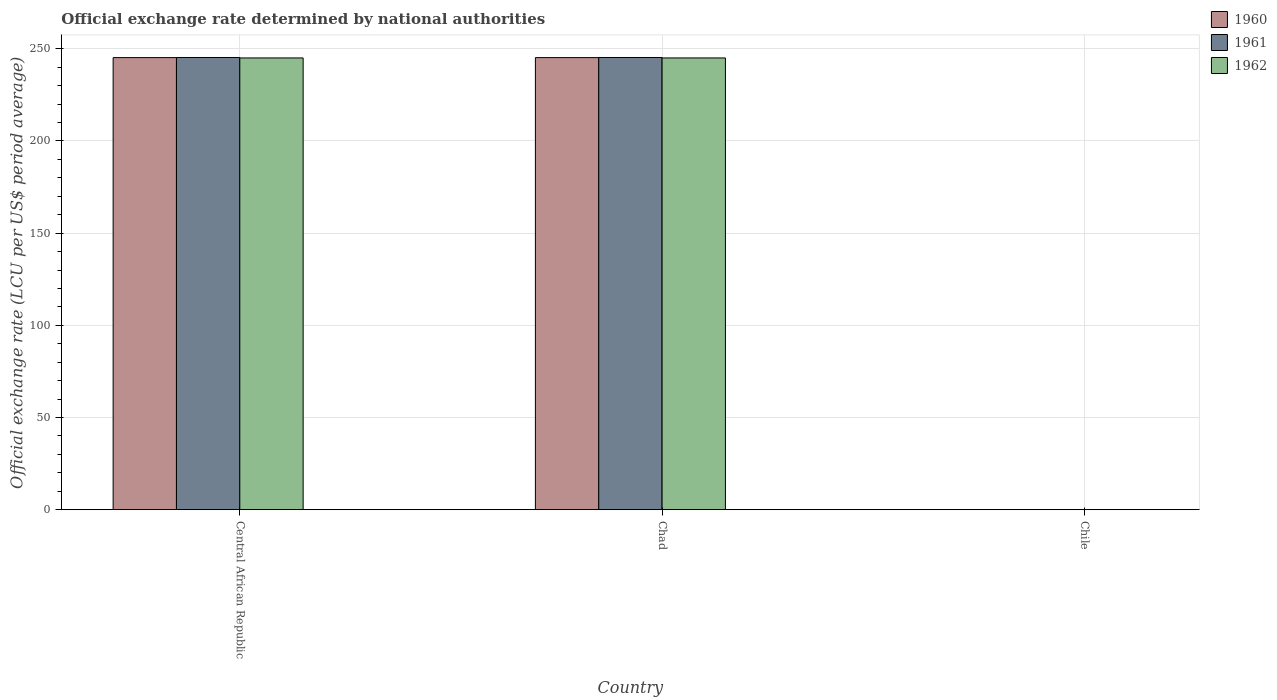How many groups of bars are there?
Offer a terse response. 3. What is the label of the 2nd group of bars from the left?
Keep it short and to the point. Chad. What is the official exchange rate in 1960 in Central African Republic?
Offer a terse response. 245.2. Across all countries, what is the maximum official exchange rate in 1961?
Your response must be concise. 245.26. Across all countries, what is the minimum official exchange rate in 1962?
Offer a terse response. 0. In which country was the official exchange rate in 1961 maximum?
Provide a succinct answer. Central African Republic. What is the total official exchange rate in 1961 in the graph?
Your answer should be very brief. 490.52. What is the difference between the official exchange rate in 1961 in Chad and that in Chile?
Provide a short and direct response. 245.26. What is the difference between the official exchange rate in 1960 in Chile and the official exchange rate in 1962 in Central African Republic?
Ensure brevity in your answer.  -245.01. What is the average official exchange rate in 1962 per country?
Ensure brevity in your answer.  163.34. What is the difference between the official exchange rate of/in 1962 and official exchange rate of/in 1960 in Chile?
Provide a short and direct response. 8.666413905490016e-6. What is the ratio of the official exchange rate in 1962 in Central African Republic to that in Chile?
Provide a short and direct response. 2.32e+05. Is the difference between the official exchange rate in 1962 in Central African Republic and Chile greater than the difference between the official exchange rate in 1960 in Central African Republic and Chile?
Give a very brief answer. No. What is the difference between the highest and the second highest official exchange rate in 1960?
Give a very brief answer. -245.19. What is the difference between the highest and the lowest official exchange rate in 1960?
Offer a terse response. 245.19. Is the sum of the official exchange rate in 1961 in Central African Republic and Chile greater than the maximum official exchange rate in 1960 across all countries?
Ensure brevity in your answer.  Yes. What does the 2nd bar from the left in Chad represents?
Offer a terse response. 1961. What does the 1st bar from the right in Central African Republic represents?
Offer a very short reply. 1962. Is it the case that in every country, the sum of the official exchange rate in 1960 and official exchange rate in 1962 is greater than the official exchange rate in 1961?
Your answer should be compact. Yes. What is the difference between two consecutive major ticks on the Y-axis?
Your answer should be compact. 50. Are the values on the major ticks of Y-axis written in scientific E-notation?
Provide a succinct answer. No. Does the graph contain any zero values?
Make the answer very short. No. Where does the legend appear in the graph?
Make the answer very short. Top right. What is the title of the graph?
Your answer should be very brief. Official exchange rate determined by national authorities. Does "1981" appear as one of the legend labels in the graph?
Give a very brief answer. No. What is the label or title of the Y-axis?
Your answer should be very brief. Official exchange rate (LCU per US$ period average). What is the Official exchange rate (LCU per US$ period average) in 1960 in Central African Republic?
Offer a very short reply. 245.2. What is the Official exchange rate (LCU per US$ period average) in 1961 in Central African Republic?
Your answer should be very brief. 245.26. What is the Official exchange rate (LCU per US$ period average) in 1962 in Central African Republic?
Your answer should be compact. 245.01. What is the Official exchange rate (LCU per US$ period average) of 1960 in Chad?
Your answer should be very brief. 245.2. What is the Official exchange rate (LCU per US$ period average) of 1961 in Chad?
Ensure brevity in your answer.  245.26. What is the Official exchange rate (LCU per US$ period average) in 1962 in Chad?
Keep it short and to the point. 245.01. What is the Official exchange rate (LCU per US$ period average) in 1960 in Chile?
Offer a terse response. 0. What is the Official exchange rate (LCU per US$ period average) in 1961 in Chile?
Keep it short and to the point. 0. What is the Official exchange rate (LCU per US$ period average) of 1962 in Chile?
Your answer should be very brief. 0. Across all countries, what is the maximum Official exchange rate (LCU per US$ period average) of 1960?
Keep it short and to the point. 245.2. Across all countries, what is the maximum Official exchange rate (LCU per US$ period average) of 1961?
Offer a very short reply. 245.26. Across all countries, what is the maximum Official exchange rate (LCU per US$ period average) of 1962?
Keep it short and to the point. 245.01. Across all countries, what is the minimum Official exchange rate (LCU per US$ period average) in 1960?
Provide a short and direct response. 0. Across all countries, what is the minimum Official exchange rate (LCU per US$ period average) of 1961?
Offer a terse response. 0. Across all countries, what is the minimum Official exchange rate (LCU per US$ period average) of 1962?
Provide a short and direct response. 0. What is the total Official exchange rate (LCU per US$ period average) of 1960 in the graph?
Your response must be concise. 490.39. What is the total Official exchange rate (LCU per US$ period average) in 1961 in the graph?
Give a very brief answer. 490.52. What is the total Official exchange rate (LCU per US$ period average) in 1962 in the graph?
Ensure brevity in your answer.  490.03. What is the difference between the Official exchange rate (LCU per US$ period average) in 1960 in Central African Republic and that in Chile?
Ensure brevity in your answer.  245.19. What is the difference between the Official exchange rate (LCU per US$ period average) in 1961 in Central African Republic and that in Chile?
Keep it short and to the point. 245.26. What is the difference between the Official exchange rate (LCU per US$ period average) in 1962 in Central African Republic and that in Chile?
Your response must be concise. 245.01. What is the difference between the Official exchange rate (LCU per US$ period average) in 1960 in Chad and that in Chile?
Provide a short and direct response. 245.19. What is the difference between the Official exchange rate (LCU per US$ period average) in 1961 in Chad and that in Chile?
Give a very brief answer. 245.26. What is the difference between the Official exchange rate (LCU per US$ period average) of 1962 in Chad and that in Chile?
Your answer should be very brief. 245.01. What is the difference between the Official exchange rate (LCU per US$ period average) in 1960 in Central African Republic and the Official exchange rate (LCU per US$ period average) in 1961 in Chad?
Provide a short and direct response. -0.07. What is the difference between the Official exchange rate (LCU per US$ period average) of 1960 in Central African Republic and the Official exchange rate (LCU per US$ period average) of 1962 in Chad?
Offer a very short reply. 0.18. What is the difference between the Official exchange rate (LCU per US$ period average) of 1961 in Central African Republic and the Official exchange rate (LCU per US$ period average) of 1962 in Chad?
Your answer should be compact. 0.25. What is the difference between the Official exchange rate (LCU per US$ period average) in 1960 in Central African Republic and the Official exchange rate (LCU per US$ period average) in 1961 in Chile?
Ensure brevity in your answer.  245.19. What is the difference between the Official exchange rate (LCU per US$ period average) in 1960 in Central African Republic and the Official exchange rate (LCU per US$ period average) in 1962 in Chile?
Offer a very short reply. 245.19. What is the difference between the Official exchange rate (LCU per US$ period average) of 1961 in Central African Republic and the Official exchange rate (LCU per US$ period average) of 1962 in Chile?
Your answer should be compact. 245.26. What is the difference between the Official exchange rate (LCU per US$ period average) in 1960 in Chad and the Official exchange rate (LCU per US$ period average) in 1961 in Chile?
Provide a short and direct response. 245.19. What is the difference between the Official exchange rate (LCU per US$ period average) of 1960 in Chad and the Official exchange rate (LCU per US$ period average) of 1962 in Chile?
Make the answer very short. 245.19. What is the difference between the Official exchange rate (LCU per US$ period average) of 1961 in Chad and the Official exchange rate (LCU per US$ period average) of 1962 in Chile?
Offer a very short reply. 245.26. What is the average Official exchange rate (LCU per US$ period average) in 1960 per country?
Provide a succinct answer. 163.46. What is the average Official exchange rate (LCU per US$ period average) in 1961 per country?
Your answer should be compact. 163.51. What is the average Official exchange rate (LCU per US$ period average) of 1962 per country?
Give a very brief answer. 163.34. What is the difference between the Official exchange rate (LCU per US$ period average) of 1960 and Official exchange rate (LCU per US$ period average) of 1961 in Central African Republic?
Your answer should be compact. -0.07. What is the difference between the Official exchange rate (LCU per US$ period average) of 1960 and Official exchange rate (LCU per US$ period average) of 1962 in Central African Republic?
Keep it short and to the point. 0.18. What is the difference between the Official exchange rate (LCU per US$ period average) of 1961 and Official exchange rate (LCU per US$ period average) of 1962 in Central African Republic?
Offer a very short reply. 0.25. What is the difference between the Official exchange rate (LCU per US$ period average) of 1960 and Official exchange rate (LCU per US$ period average) of 1961 in Chad?
Your response must be concise. -0.07. What is the difference between the Official exchange rate (LCU per US$ period average) in 1960 and Official exchange rate (LCU per US$ period average) in 1962 in Chad?
Keep it short and to the point. 0.18. What is the difference between the Official exchange rate (LCU per US$ period average) in 1961 and Official exchange rate (LCU per US$ period average) in 1962 in Chad?
Give a very brief answer. 0.25. What is the difference between the Official exchange rate (LCU per US$ period average) in 1960 and Official exchange rate (LCU per US$ period average) in 1961 in Chile?
Provide a succinct answer. -0. What is the difference between the Official exchange rate (LCU per US$ period average) of 1960 and Official exchange rate (LCU per US$ period average) of 1962 in Chile?
Ensure brevity in your answer.  -0. What is the ratio of the Official exchange rate (LCU per US$ period average) of 1960 in Central African Republic to that in Chile?
Give a very brief answer. 2.34e+05. What is the ratio of the Official exchange rate (LCU per US$ period average) in 1961 in Central African Republic to that in Chile?
Your answer should be very brief. 2.34e+05. What is the ratio of the Official exchange rate (LCU per US$ period average) of 1962 in Central African Republic to that in Chile?
Your response must be concise. 2.32e+05. What is the ratio of the Official exchange rate (LCU per US$ period average) in 1960 in Chad to that in Chile?
Your answer should be very brief. 2.34e+05. What is the ratio of the Official exchange rate (LCU per US$ period average) of 1961 in Chad to that in Chile?
Offer a terse response. 2.34e+05. What is the ratio of the Official exchange rate (LCU per US$ period average) in 1962 in Chad to that in Chile?
Offer a terse response. 2.32e+05. What is the difference between the highest and the second highest Official exchange rate (LCU per US$ period average) in 1960?
Make the answer very short. 0. What is the difference between the highest and the second highest Official exchange rate (LCU per US$ period average) of 1961?
Provide a short and direct response. 0. What is the difference between the highest and the lowest Official exchange rate (LCU per US$ period average) in 1960?
Offer a terse response. 245.19. What is the difference between the highest and the lowest Official exchange rate (LCU per US$ period average) in 1961?
Ensure brevity in your answer.  245.26. What is the difference between the highest and the lowest Official exchange rate (LCU per US$ period average) of 1962?
Make the answer very short. 245.01. 